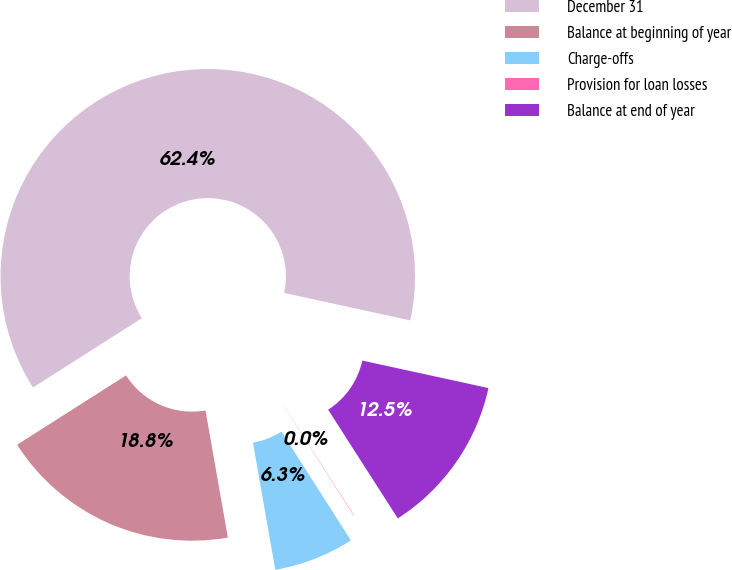Convert chart to OTSL. <chart><loc_0><loc_0><loc_500><loc_500><pie_chart><fcel>December 31<fcel>Balance at beginning of year<fcel>Charge-offs<fcel>Provision for loan losses<fcel>Balance at end of year<nl><fcel>62.43%<fcel>18.75%<fcel>6.27%<fcel>0.03%<fcel>12.51%<nl></chart> 